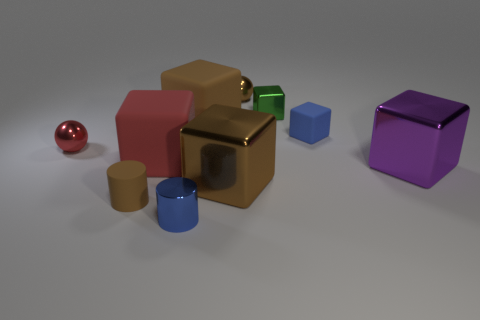Are there fewer blue cylinders than small brown matte blocks? After analyzing the image, it appears that this is not the case. There are actually an equal number of blue cylinders and small brown matte blocks, with each category having one item visible. 